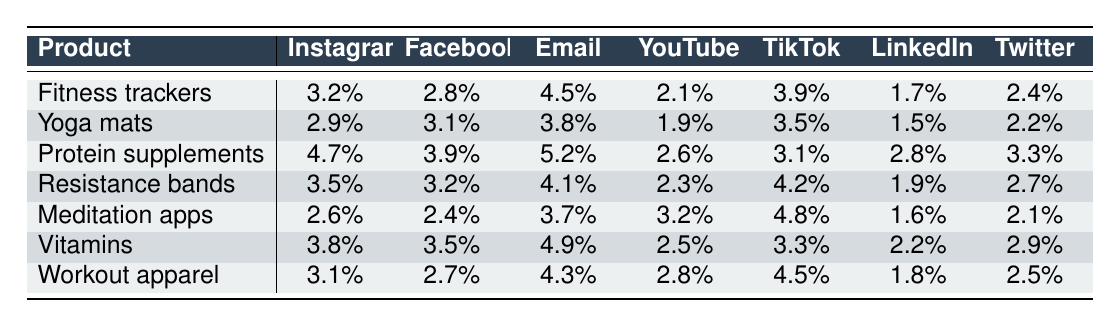What is the highest conversion rate among fitness trackers across all channels? The conversion rate for fitness trackers is highest on Email with a rate of 4.5%. I found this by looking at the row for fitness trackers and identifying the highest value across the channels listed.
Answer: 4.5% Which channel has the lowest conversion rate for meditation apps? The conversion rate for meditation apps on LinkedIn is the lowest at 1.6%. This was found by checking the row for meditation apps and comparing the values across all channels.
Answer: 1.6% What is the average conversion rate for yoga mats? To find the average conversion rate for yoga mats, I sum the values (2.9 + 3.1 + 3.8 + 1.9 + 3.5 + 1.5 + 2.2 = 19.9) and divide by the number of channels (7), which results in approximately 2.84.
Answer: 2.84% True or False: The conversion rate for protein supplements is higher on Instagram than on YouTube. The conversion rate for protein supplements on Instagram is 4.7%, whereas on YouTube, it is 2.6%. Since 4.7% is greater than 2.6%, the statement is true.
Answer: True What is the total conversion rate for workout apparel across all channels? The total conversion rate for workout apparel is calculated by adding all conversion rates for that product (3.1 + 2.7 + 4.3 + 2.8 + 4.5 + 1.8 + 2.5 = 21.7).
Answer: 21.7 Which product has the highest average conversion rate across all channels? Calculating the average conversion rate for each product, protein supplements have the highest average at approximately 4.05% (5.2 + 4.7 + 3.9 + 3.3 + 2.8 + 2.6 + 3.1) divided by 7, which is more than others.
Answer: Protein supplements What is the difference in conversion rates between vitamins on Facebook and resistance bands on Instagram? The conversion rate for vitamins on Facebook is 3.5%, while for resistance bands on Instagram, it is 3.5%. The difference is 3.5% - 3.5% = 0%, meaning they are the same.
Answer: 0% Identify the channel with the highest overall conversion rate across all products. To determine the highest overall conversion rate, I calculated the sums of conversion rates for each channel: Instagram (17.9), Facebook (17.2), Email (25.0), YouTube (14.3), TikTok (23.2), LinkedIn (15.5), and Twitter (18.2). The highest sum is for Email with 25.0%.
Answer: Email How does the conversion rate for fitness trackers on TikTok compare to the conversion rate for meditation apps on YouTube? The conversion rate for fitness trackers on TikTok is 3.9%, while for meditation apps on YouTube, it is 3.2%. Comparing these values shows that the conversion rate for fitness trackers is higher by 0.7%.
Answer: 0.7% higher What is the median conversion rate for protein supplements across all channels? Listing the conversion rates for protein supplements: 4.7, 3.9, 5.2, 2.6, 3.1, 2.8, 3.3. Sorting these values gives: 2.6, 2.8, 3.1, 3.3, 3.9, 4.7, 5.2. The median, which is the middle value, is 3.3.
Answer: 3.3 